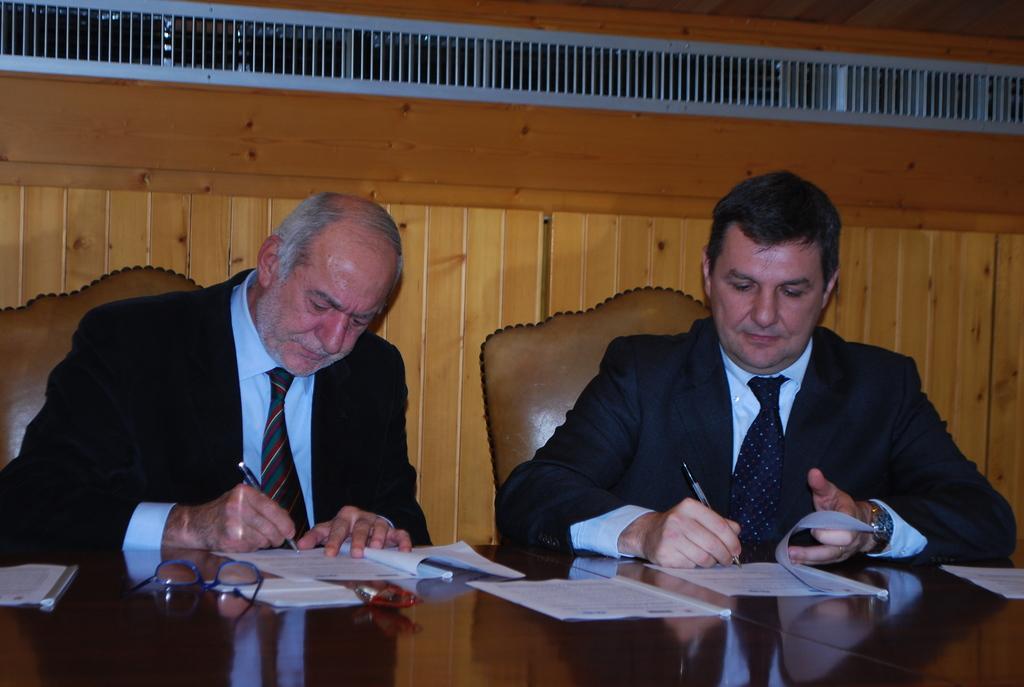Can you describe this image briefly? In this image we can see people writing on the papers. At the bottom there is a table and we can see glasses and papers placed on the table. In the background there is a wall and we can see grille. 